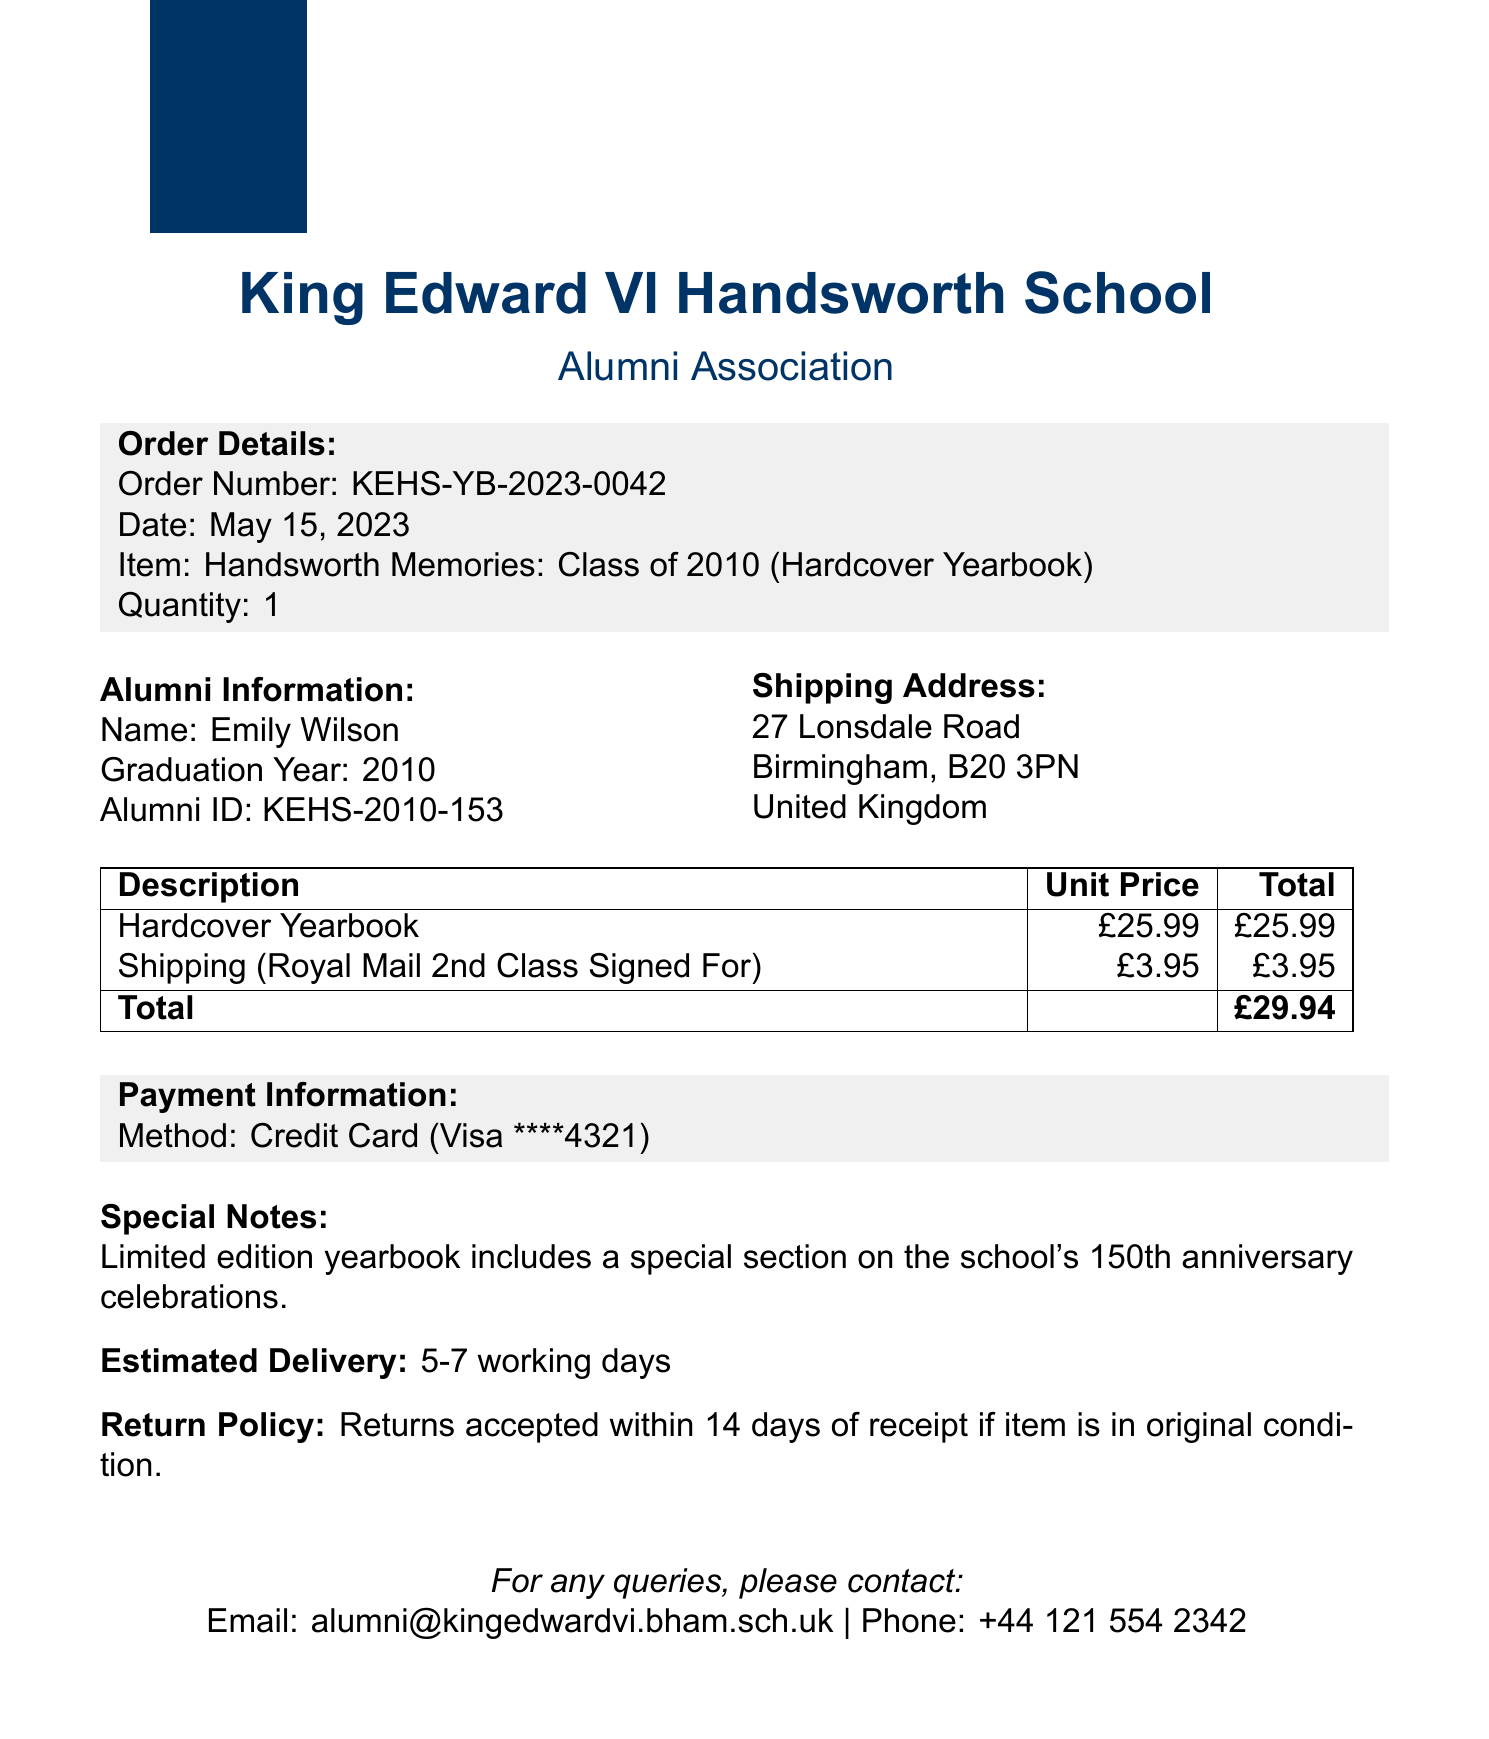What is the title of the yearbook? The title of the yearbook is specified in the document, which is "Handsworth Memories: Class of 2010."
Answer: Handsworth Memories: Class of 2010 Who is the purchaser of the yearbook? The purchaser's name is given in the alumni details section of the document.
Answer: Emily Wilson What is the purchase date? The purchase date is mentioned clearly in the document as the date of the transaction.
Answer: May 15, 2023 What is the shipping cost? The cost of shipping is listed in the cost breakdown section of the document.
Answer: 3.95 What is the total amount charged? The total cost of the transaction is provided in the cost breakdown.
Answer: 29.94 What form of payment was used? The payment method is clearly stated in the payment details section of the document as the type of card used.
Answer: Credit Card How long is the estimated delivery timeframe? The estimated delivery time is explicitly noted in the document as a range of days.
Answer: 5-7 working days What is the return policy period? The return policy is described in the document, specifying the number of days allowed for returns.
Answer: 14 days Which carrier is used for shipping? The document specifies the carrier service that will deliver the yearbook.
Answer: Royal Mail 